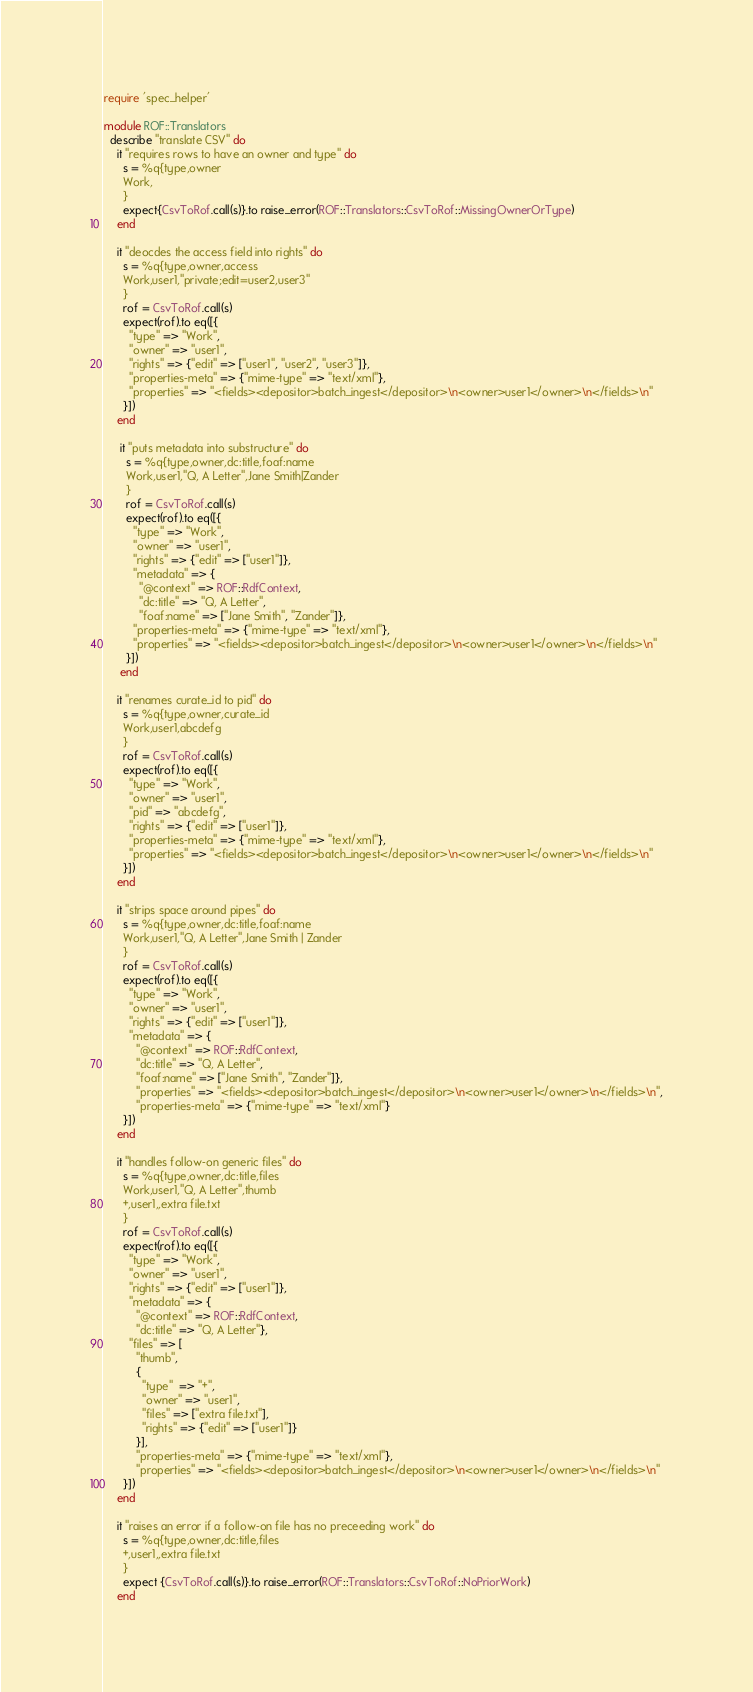<code> <loc_0><loc_0><loc_500><loc_500><_Ruby_>require 'spec_helper'

module ROF::Translators
  describe "translate CSV" do
    it "requires rows to have an owner and type" do
      s = %q{type,owner
      Work,
      }
      expect{CsvToRof.call(s)}.to raise_error(ROF::Translators::CsvToRof::MissingOwnerOrType)
    end

    it "deocdes the access field into rights" do
      s = %q{type,owner,access
      Work,user1,"private;edit=user2,user3"
      }
      rof = CsvToRof.call(s)
      expect(rof).to eq([{
        "type" => "Work",
        "owner" => "user1", 
        "rights" => {"edit" => ["user1", "user2", "user3"]},
        "properties-meta" => {"mime-type" => "text/xml"},
        "properties" => "<fields><depositor>batch_ingest</depositor>\n<owner>user1</owner>\n</fields>\n"
      }])
    end

     it "puts metadata into substructure" do
       s = %q{type,owner,dc:title,foaf:name
       Work,user1,"Q, A Letter",Jane Smith|Zander
       }
       rof = CsvToRof.call(s)
       expect(rof).to eq([{
         "type" => "Work",
         "owner" => "user1",
         "rights" => {"edit" => ["user1"]},
         "metadata" => {
           "@context" => ROF::RdfContext,
           "dc:title" => "Q, A Letter",
           "foaf:name" => ["Jane Smith", "Zander"]},
         "properties-meta" => {"mime-type" => "text/xml"},
         "properties" => "<fields><depositor>batch_ingest</depositor>\n<owner>user1</owner>\n</fields>\n"
       }])
     end

    it "renames curate_id to pid" do
      s = %q{type,owner,curate_id
      Work,user1,abcdefg
      }
      rof = CsvToRof.call(s)
      expect(rof).to eq([{
        "type" => "Work",
        "owner" => "user1",
        "pid" => "abcdefg",
        "rights" => {"edit" => ["user1"]},
        "properties-meta" => {"mime-type" => "text/xml"},
        "properties" => "<fields><depositor>batch_ingest</depositor>\n<owner>user1</owner>\n</fields>\n"
      }])
    end

    it "strips space around pipes" do
      s = %q{type,owner,dc:title,foaf:name
      Work,user1,"Q, A Letter",Jane Smith | Zander
      }
      rof = CsvToRof.call(s)
      expect(rof).to eq([{
        "type" => "Work",
        "owner" => "user1",
        "rights" => {"edit" => ["user1"]},
        "metadata" => {
          "@context" => ROF::RdfContext,
          "dc:title" => "Q, A Letter",
          "foaf:name" => ["Jane Smith", "Zander"]},
          "properties" => "<fields><depositor>batch_ingest</depositor>\n<owner>user1</owner>\n</fields>\n",
          "properties-meta" => {"mime-type" => "text/xml"}
      }])
    end

    it "handles follow-on generic files" do
      s = %q{type,owner,dc:title,files
      Work,user1,"Q, A Letter",thumb
      +,user1,,extra file.txt
      }
      rof = CsvToRof.call(s)
      expect(rof).to eq([{
        "type" => "Work",
        "owner" => "user1",
        "rights" => {"edit" => ["user1"]},
        "metadata" => {
          "@context" => ROF::RdfContext,
          "dc:title" => "Q, A Letter"},
        "files" => [
          "thumb",
          {
            "type"  => "+",
            "owner" => "user1",
            "files" => ["extra file.txt"],
            "rights" => {"edit" => ["user1"]}
          }],
          "properties-meta" => {"mime-type" => "text/xml"},
          "properties" => "<fields><depositor>batch_ingest</depositor>\n<owner>user1</owner>\n</fields>\n"
      }])
    end

    it "raises an error if a follow-on file has no preceeding work" do
      s = %q{type,owner,dc:title,files
      +,user1,,extra file.txt
      }
      expect {CsvToRof.call(s)}.to raise_error(ROF::Translators::CsvToRof::NoPriorWork)
    end
</code> 